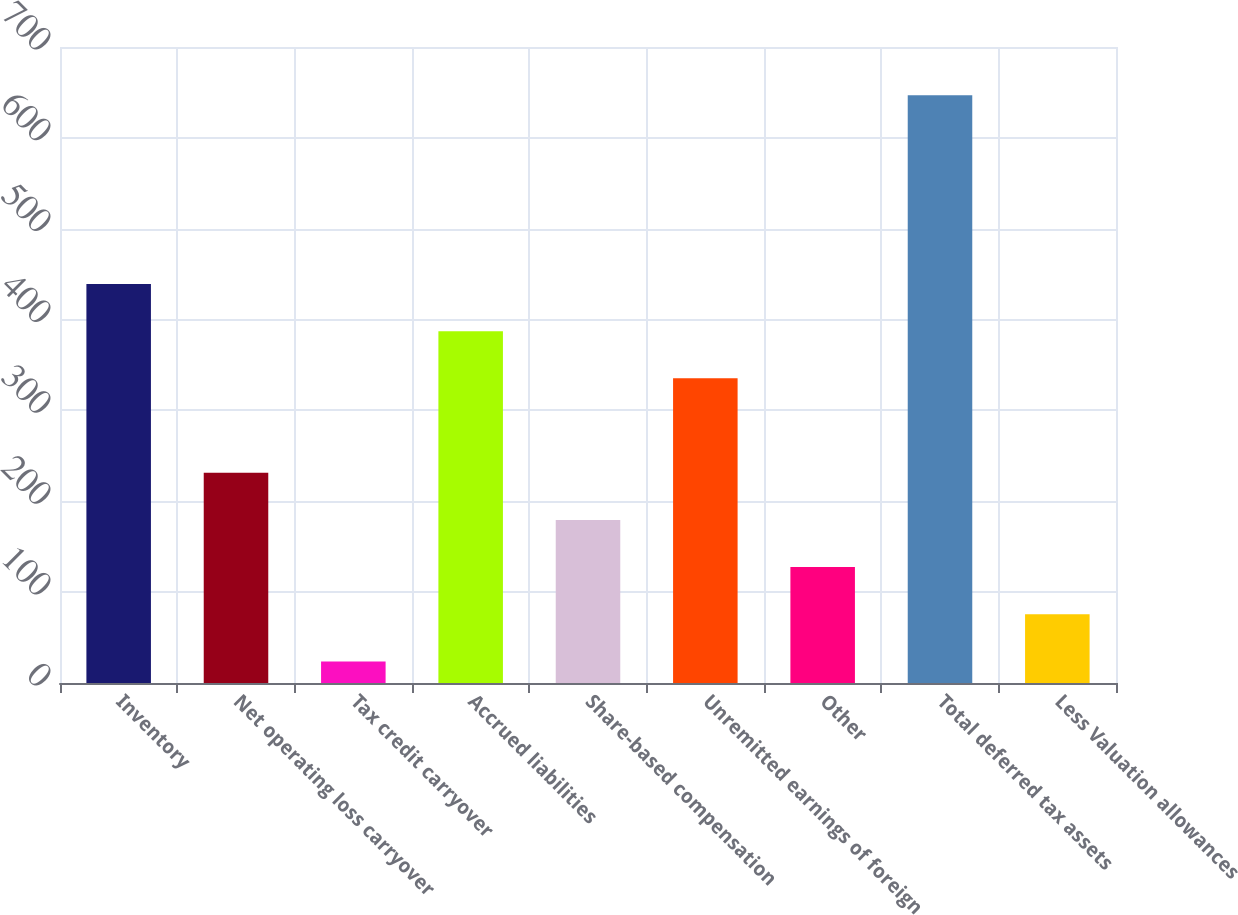Convert chart to OTSL. <chart><loc_0><loc_0><loc_500><loc_500><bar_chart><fcel>Inventory<fcel>Net operating loss carryover<fcel>Tax credit carryover<fcel>Accrued liabilities<fcel>Share-based compensation<fcel>Unremitted earnings of foreign<fcel>Other<fcel>Total deferred tax assets<fcel>Less Valuation allowances<nl><fcel>439.22<fcel>231.46<fcel>23.7<fcel>387.28<fcel>179.52<fcel>335.34<fcel>127.58<fcel>646.98<fcel>75.64<nl></chart> 